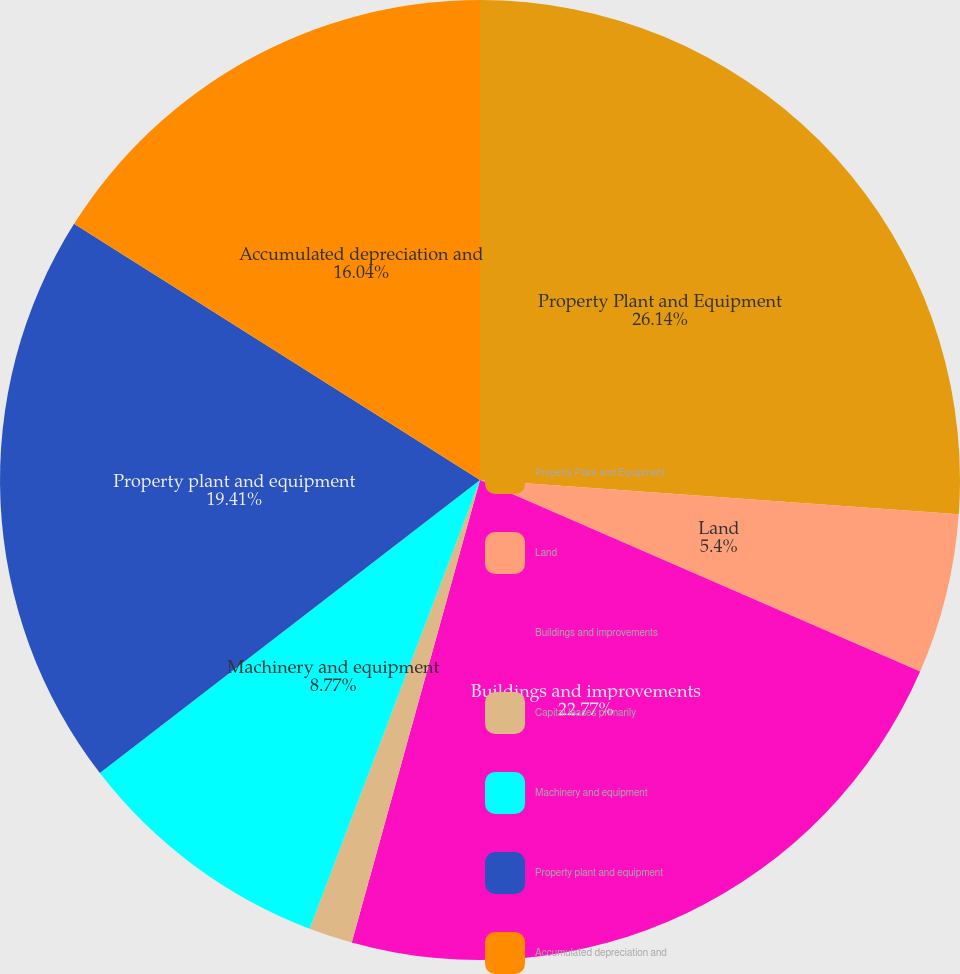Convert chart to OTSL. <chart><loc_0><loc_0><loc_500><loc_500><pie_chart><fcel>Property Plant and Equipment<fcel>Land<fcel>Buildings and improvements<fcel>Capital leases primarily<fcel>Machinery and equipment<fcel>Property plant and equipment<fcel>Accumulated depreciation and<nl><fcel>26.13%<fcel>5.4%<fcel>22.77%<fcel>1.47%<fcel>8.77%<fcel>19.41%<fcel>16.04%<nl></chart> 